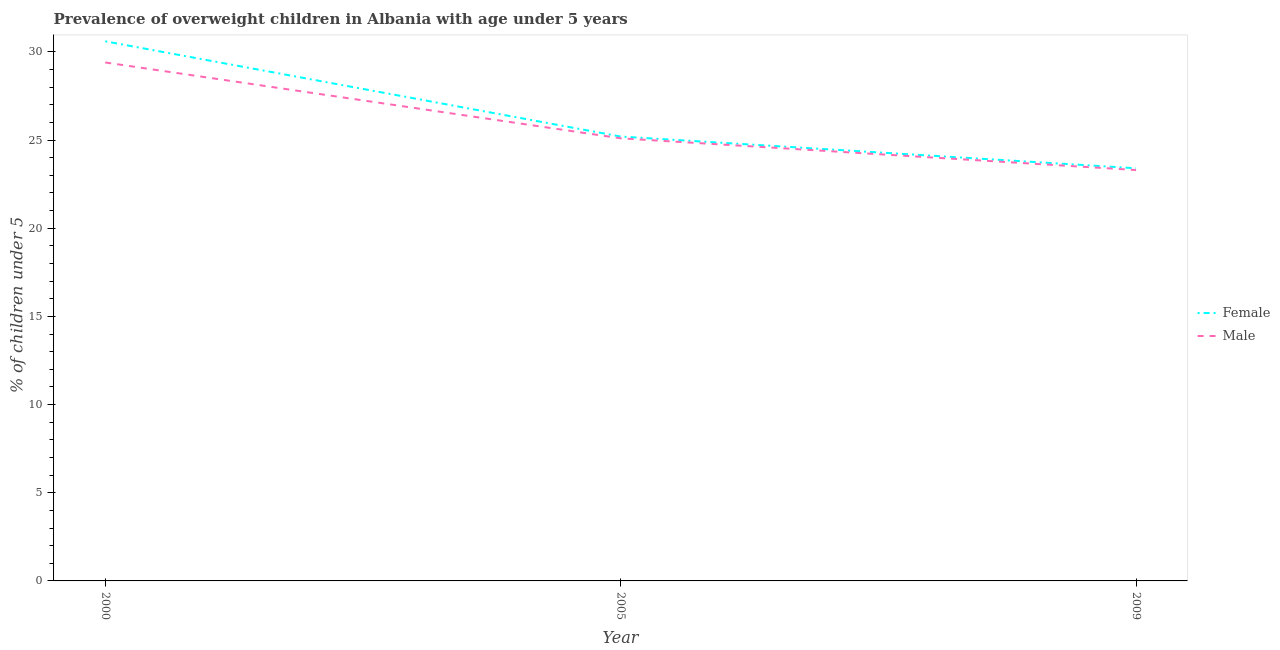How many different coloured lines are there?
Offer a very short reply. 2. Is the number of lines equal to the number of legend labels?
Ensure brevity in your answer.  Yes. What is the percentage of obese male children in 2005?
Make the answer very short. 25.1. Across all years, what is the maximum percentage of obese female children?
Provide a succinct answer. 30.6. Across all years, what is the minimum percentage of obese male children?
Provide a succinct answer. 23.3. In which year was the percentage of obese female children maximum?
Keep it short and to the point. 2000. What is the total percentage of obese female children in the graph?
Ensure brevity in your answer.  79.2. What is the difference between the percentage of obese male children in 2000 and that in 2005?
Give a very brief answer. 4.3. What is the difference between the percentage of obese male children in 2009 and the percentage of obese female children in 2000?
Provide a succinct answer. -7.3. What is the average percentage of obese female children per year?
Provide a succinct answer. 26.4. In the year 2000, what is the difference between the percentage of obese female children and percentage of obese male children?
Your answer should be very brief. 1.2. What is the ratio of the percentage of obese male children in 2005 to that in 2009?
Your answer should be compact. 1.08. Is the percentage of obese female children in 2000 less than that in 2005?
Offer a very short reply. No. What is the difference between the highest and the second highest percentage of obese male children?
Your answer should be very brief. 4.3. What is the difference between the highest and the lowest percentage of obese male children?
Offer a very short reply. 6.1. In how many years, is the percentage of obese female children greater than the average percentage of obese female children taken over all years?
Your response must be concise. 1. Is the sum of the percentage of obese male children in 2000 and 2009 greater than the maximum percentage of obese female children across all years?
Ensure brevity in your answer.  Yes. Does the percentage of obese male children monotonically increase over the years?
Your answer should be very brief. No. How many lines are there?
Your answer should be very brief. 2. Does the graph contain grids?
Ensure brevity in your answer.  No. Where does the legend appear in the graph?
Offer a very short reply. Center right. How many legend labels are there?
Your answer should be very brief. 2. How are the legend labels stacked?
Make the answer very short. Vertical. What is the title of the graph?
Your answer should be compact. Prevalence of overweight children in Albania with age under 5 years. Does "Enforce a contract" appear as one of the legend labels in the graph?
Offer a very short reply. No. What is the label or title of the X-axis?
Your answer should be very brief. Year. What is the label or title of the Y-axis?
Make the answer very short.  % of children under 5. What is the  % of children under 5 in Female in 2000?
Offer a very short reply. 30.6. What is the  % of children under 5 in Male in 2000?
Ensure brevity in your answer.  29.4. What is the  % of children under 5 of Female in 2005?
Your answer should be very brief. 25.2. What is the  % of children under 5 of Male in 2005?
Make the answer very short. 25.1. What is the  % of children under 5 of Female in 2009?
Offer a terse response. 23.4. What is the  % of children under 5 in Male in 2009?
Make the answer very short. 23.3. Across all years, what is the maximum  % of children under 5 in Female?
Provide a short and direct response. 30.6. Across all years, what is the maximum  % of children under 5 in Male?
Give a very brief answer. 29.4. Across all years, what is the minimum  % of children under 5 in Female?
Ensure brevity in your answer.  23.4. Across all years, what is the minimum  % of children under 5 of Male?
Ensure brevity in your answer.  23.3. What is the total  % of children under 5 in Female in the graph?
Offer a very short reply. 79.2. What is the total  % of children under 5 of Male in the graph?
Offer a very short reply. 77.8. What is the difference between the  % of children under 5 in Male in 2000 and that in 2005?
Ensure brevity in your answer.  4.3. What is the difference between the  % of children under 5 in Female in 2000 and that in 2009?
Provide a short and direct response. 7.2. What is the difference between the  % of children under 5 of Male in 2000 and that in 2009?
Offer a very short reply. 6.1. What is the difference between the  % of children under 5 in Female in 2000 and the  % of children under 5 in Male in 2005?
Offer a terse response. 5.5. What is the difference between the  % of children under 5 of Female in 2000 and the  % of children under 5 of Male in 2009?
Keep it short and to the point. 7.3. What is the difference between the  % of children under 5 in Female in 2005 and the  % of children under 5 in Male in 2009?
Provide a short and direct response. 1.9. What is the average  % of children under 5 of Female per year?
Keep it short and to the point. 26.4. What is the average  % of children under 5 of Male per year?
Keep it short and to the point. 25.93. In the year 2000, what is the difference between the  % of children under 5 in Female and  % of children under 5 in Male?
Your response must be concise. 1.2. In the year 2009, what is the difference between the  % of children under 5 in Female and  % of children under 5 in Male?
Provide a short and direct response. 0.1. What is the ratio of the  % of children under 5 in Female in 2000 to that in 2005?
Give a very brief answer. 1.21. What is the ratio of the  % of children under 5 in Male in 2000 to that in 2005?
Make the answer very short. 1.17. What is the ratio of the  % of children under 5 of Female in 2000 to that in 2009?
Your answer should be compact. 1.31. What is the ratio of the  % of children under 5 of Male in 2000 to that in 2009?
Ensure brevity in your answer.  1.26. What is the ratio of the  % of children under 5 of Female in 2005 to that in 2009?
Ensure brevity in your answer.  1.08. What is the ratio of the  % of children under 5 of Male in 2005 to that in 2009?
Provide a succinct answer. 1.08. What is the difference between the highest and the second highest  % of children under 5 in Male?
Offer a very short reply. 4.3. What is the difference between the highest and the lowest  % of children under 5 of Female?
Offer a very short reply. 7.2. 